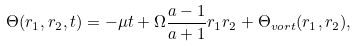<formula> <loc_0><loc_0><loc_500><loc_500>\Theta ( r _ { 1 } , r _ { 2 } , t ) = - \mu t + \Omega \frac { a - 1 } { a + 1 } r _ { 1 } r _ { 2 } + \Theta _ { v o r t } ( r _ { 1 } , r _ { 2 } ) ,</formula> 